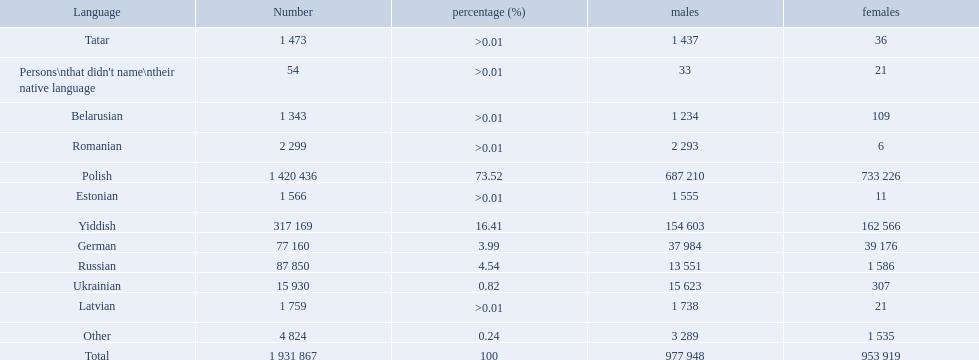What are all the languages? Polish, Yiddish, Russian, German, Ukrainian, Romanian, Latvian, Estonian, Tatar, Belarusian, Other. Which only have percentages >0.01? Romanian, Latvian, Estonian, Tatar, Belarusian. Of these, which has the greatest number of speakers? Romanian. What were all the languages? Polish, Yiddish, Russian, German, Ukrainian, Romanian, Latvian, Estonian, Tatar, Belarusian, Other, Persons\nthat didn't name\ntheir native language. For these, how many people spoke them? 1 420 436, 317 169, 87 850, 77 160, 15 930, 2 299, 1 759, 1 566, 1 473, 1 343, 4 824, 54. Of these, which is the largest number of speakers? 1 420 436. Which language corresponds to this number? Polish. 